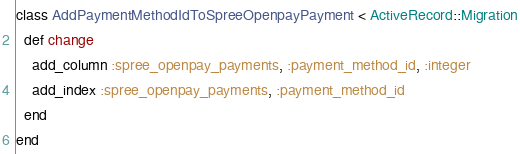Convert code to text. <code><loc_0><loc_0><loc_500><loc_500><_Ruby_>class AddPaymentMethodIdToSpreeOpenpayPayment < ActiveRecord::Migration
  def change
    add_column :spree_openpay_payments, :payment_method_id, :integer
    add_index :spree_openpay_payments, :payment_method_id
  end
end
</code> 